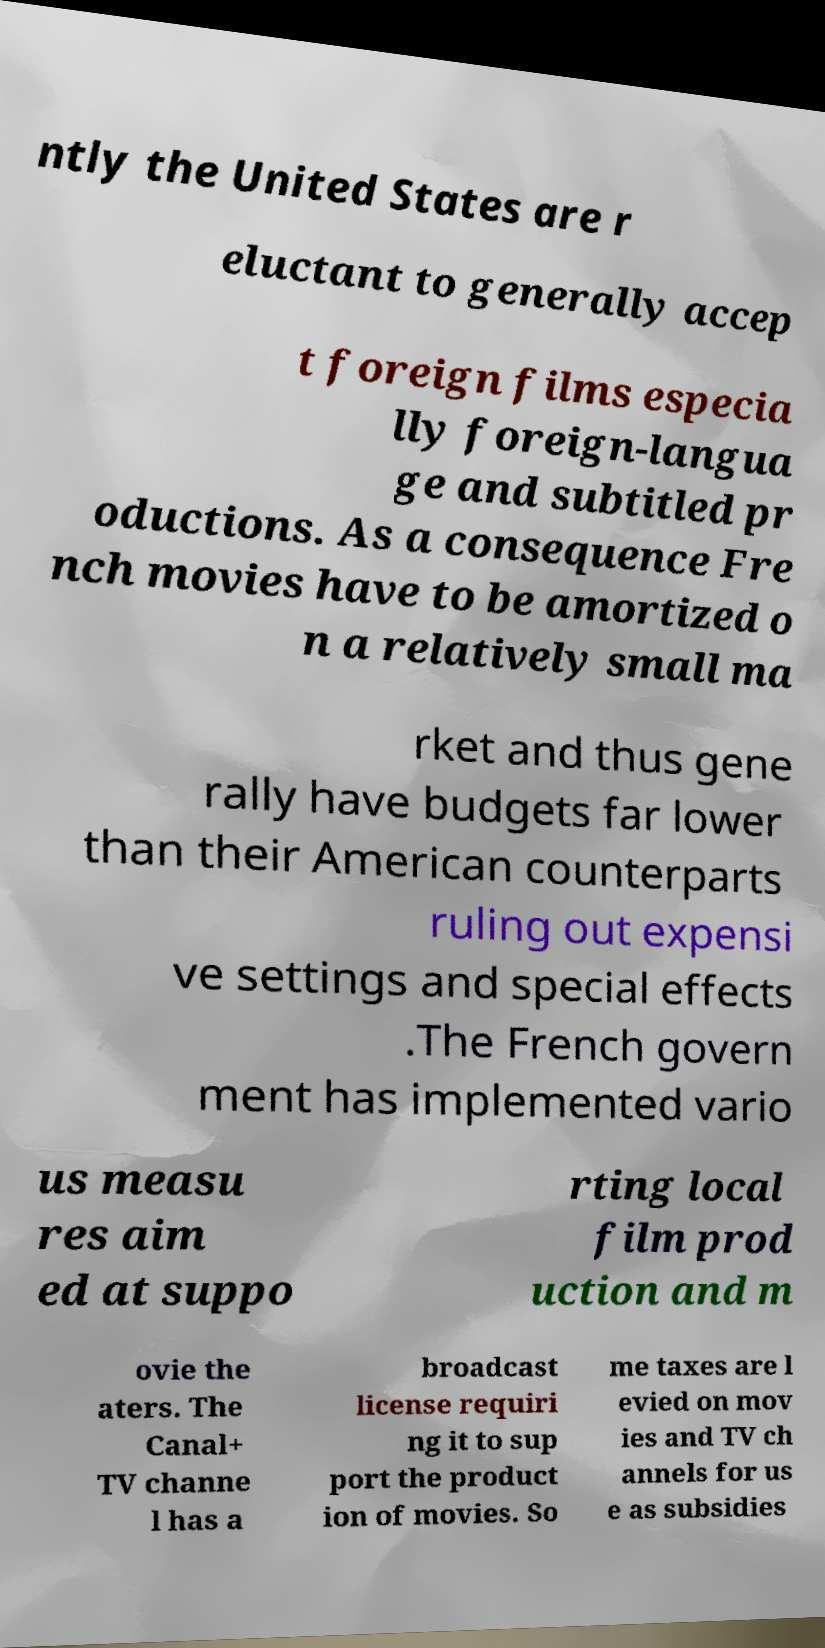Could you extract and type out the text from this image? ntly the United States are r eluctant to generally accep t foreign films especia lly foreign-langua ge and subtitled pr oductions. As a consequence Fre nch movies have to be amortized o n a relatively small ma rket and thus gene rally have budgets far lower than their American counterparts ruling out expensi ve settings and special effects .The French govern ment has implemented vario us measu res aim ed at suppo rting local film prod uction and m ovie the aters. The Canal+ TV channe l has a broadcast license requiri ng it to sup port the product ion of movies. So me taxes are l evied on mov ies and TV ch annels for us e as subsidies 